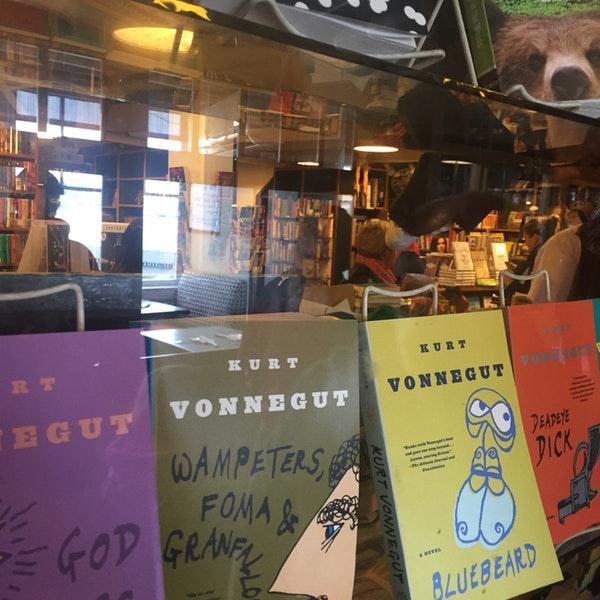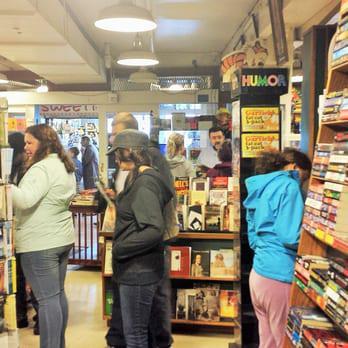The first image is the image on the left, the second image is the image on the right. Considering the images on both sides, is "The man behind the counter has a beard." valid? Answer yes or no. Yes. 